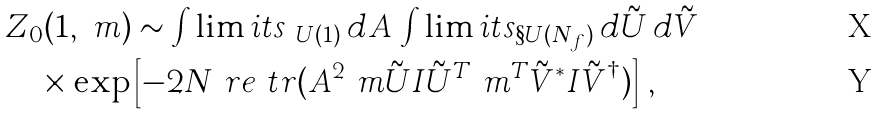<formula> <loc_0><loc_0><loc_500><loc_500>& Z _ { 0 } ( 1 , \ m ) \sim \int \lim i t s _ { \ U ( 1 ) } \, d A \, \int \lim i t s _ { \S U ( N _ { f } ) } \, d \tilde { U } \, d \tilde { V } \\ & \quad \times \exp \left [ - 2 N \ r e \ t r ( A ^ { 2 } \ m \tilde { U } I \tilde { U } ^ { T } \ m ^ { T } \tilde { V } ^ { * } I \tilde { V } ^ { \dagger } ) \right ] \, ,</formula> 